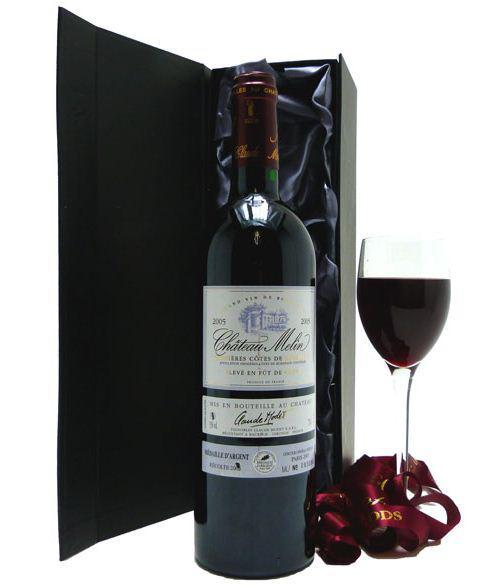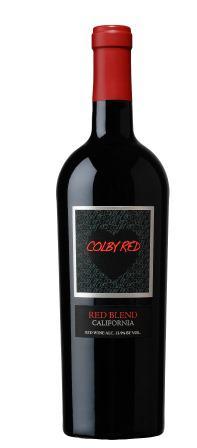The first image is the image on the left, the second image is the image on the right. Evaluate the accuracy of this statement regarding the images: "The right image contains exactly three wine bottles in a horizontal row.". Is it true? Answer yes or no. No. The first image is the image on the left, the second image is the image on the right. For the images shown, is this caption "One image shows exactly three bottles, all with the same shape and same bottle color." true? Answer yes or no. No. 